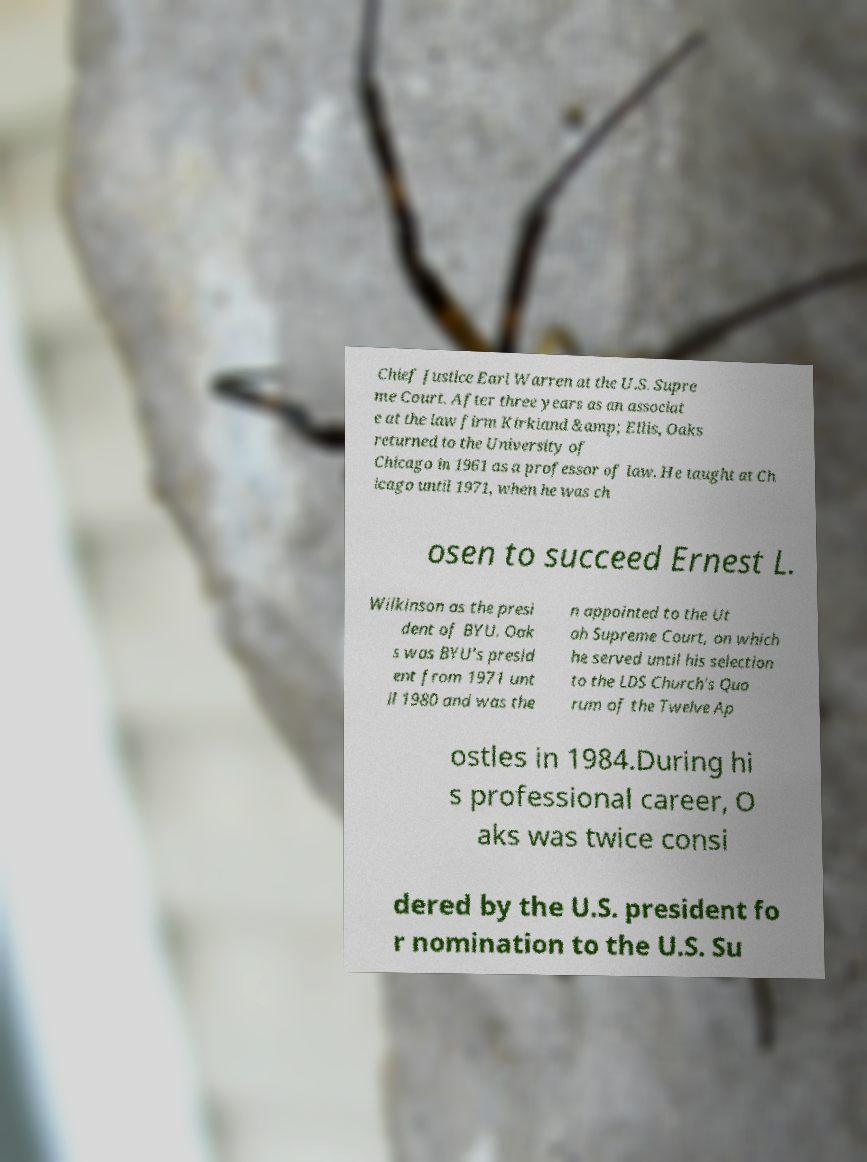What messages or text are displayed in this image? I need them in a readable, typed format. Chief Justice Earl Warren at the U.S. Supre me Court. After three years as an associat e at the law firm Kirkland &amp; Ellis, Oaks returned to the University of Chicago in 1961 as a professor of law. He taught at Ch icago until 1971, when he was ch osen to succeed Ernest L. Wilkinson as the presi dent of BYU. Oak s was BYU's presid ent from 1971 unt il 1980 and was the n appointed to the Ut ah Supreme Court, on which he served until his selection to the LDS Church's Quo rum of the Twelve Ap ostles in 1984.During hi s professional career, O aks was twice consi dered by the U.S. president fo r nomination to the U.S. Su 